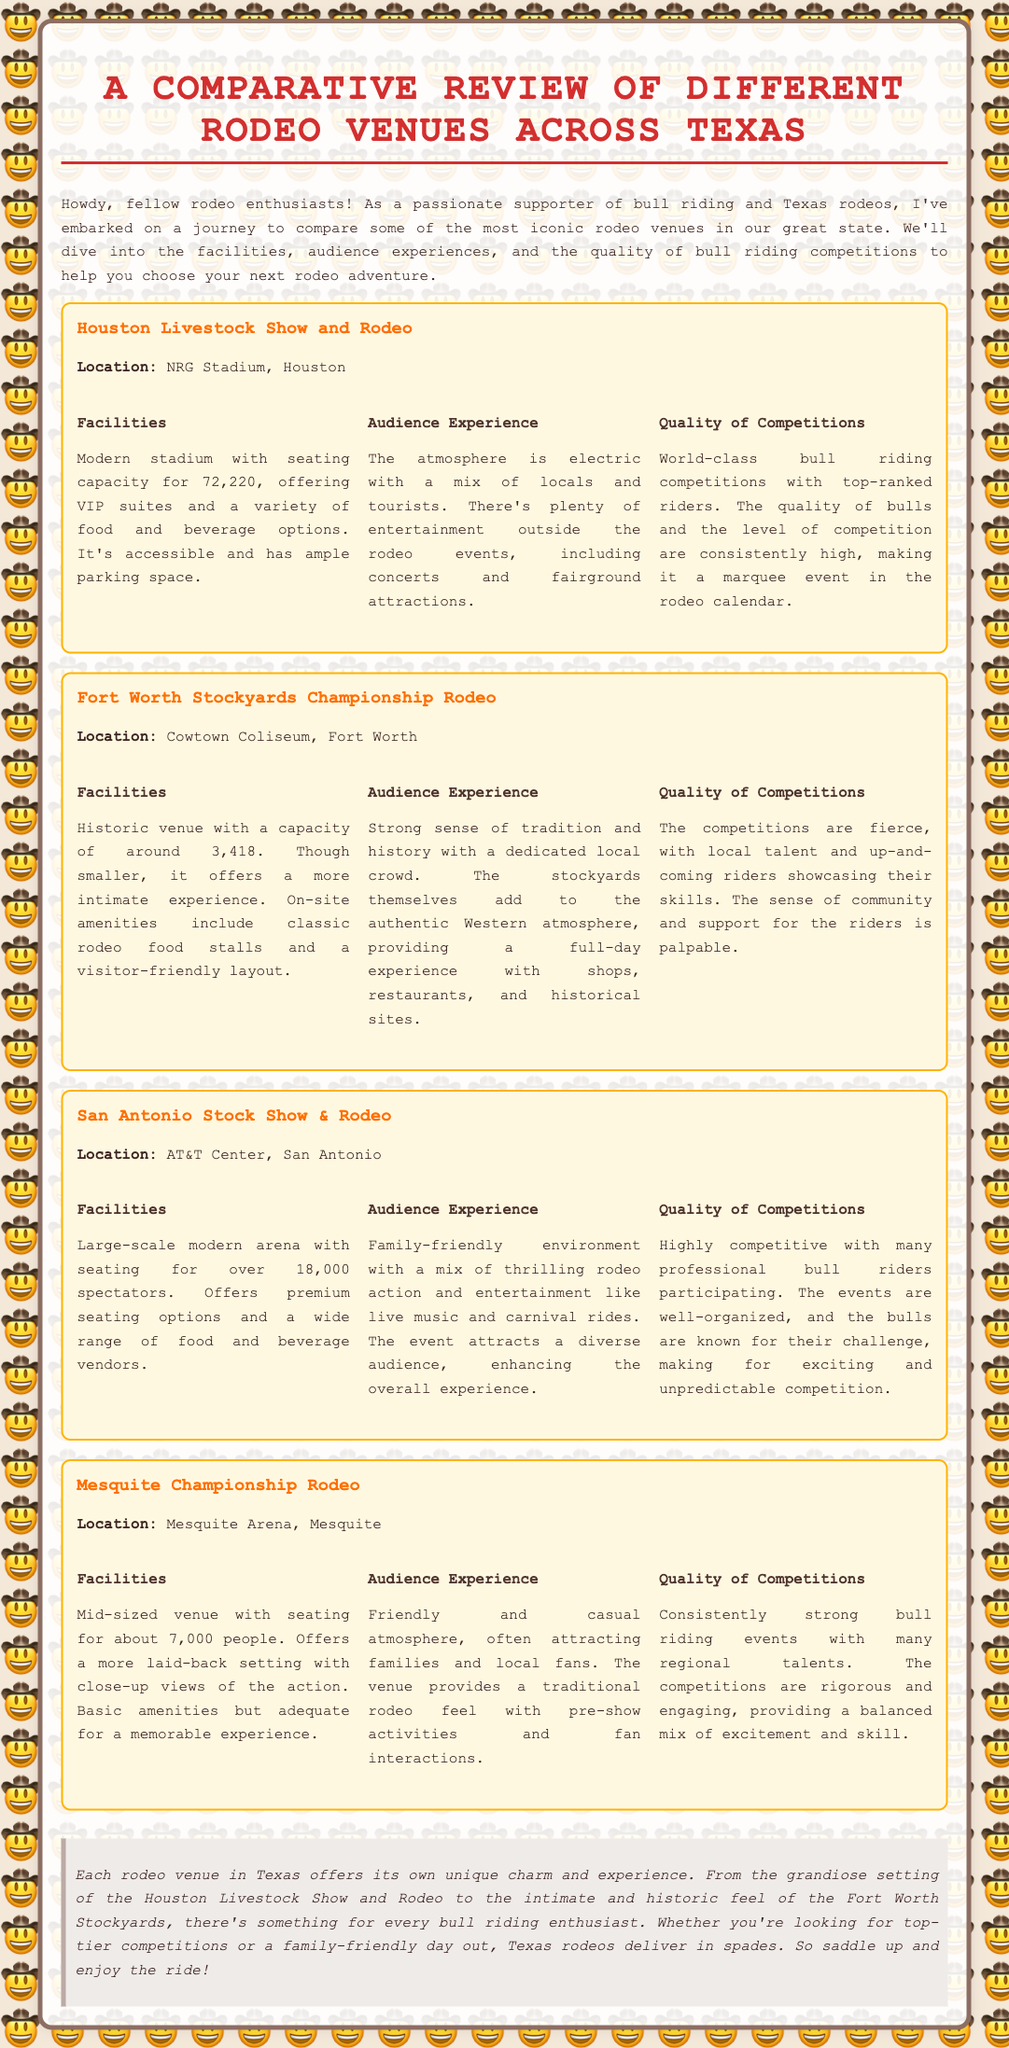What is the seating capacity of the Houston Livestock Show and Rodeo? The document states that the Houston Livestock Show and Rodeo has a seating capacity for 72,220 attendees.
Answer: 72,220 What is the location of the Fort Worth Stockyards Championship Rodeo? The document mentions that it is held at the Cowtown Coliseum in Fort Worth, Texas.
Answer: Cowtown Coliseum, Fort Worth What type of atmosphere does the San Antonio Stock Show & Rodeo have? The document describes the audience experience as family-friendly with a mix of thrilling rodeo action and entertainment.
Answer: Family-friendly How many people can the Mesquite Arena accommodate? The document indicates that the Mesquite Arena has a seating capacity for about 7,000 people.
Answer: About 7,000 What is one reason the audience enjoys the Fort Worth Stockyards? The document highlights a strong sense of tradition and history at the Fort Worth Stockyards Championship Rodeo.
Answer: Tradition and history Which rodeo venue is known for world-class bull riding competitions? According to the document, the Houston Livestock Show and Rodeo is recognized for its world-class bull riding competitions.
Answer: Houston Livestock Show and Rodeo What amenities does the San Antonio Stock Show & Rodeo offer? The document mentions that it offers premium seating options and a wide range of food and beverage vendors.
Answer: Premium seating and food options What unique experience does the Mesquite Championship Rodeo provide? The document states that it offers a friendly and casual atmosphere with fan interactions.
Answer: Casual atmosphere and fan interactions Which venue has the largest audience capacity among the ones listed? The document specifies that the Houston Livestock Show and Rodeo has the largest audience capacity at 72,220.
Answer: Houston Livestock Show and Rodeo 